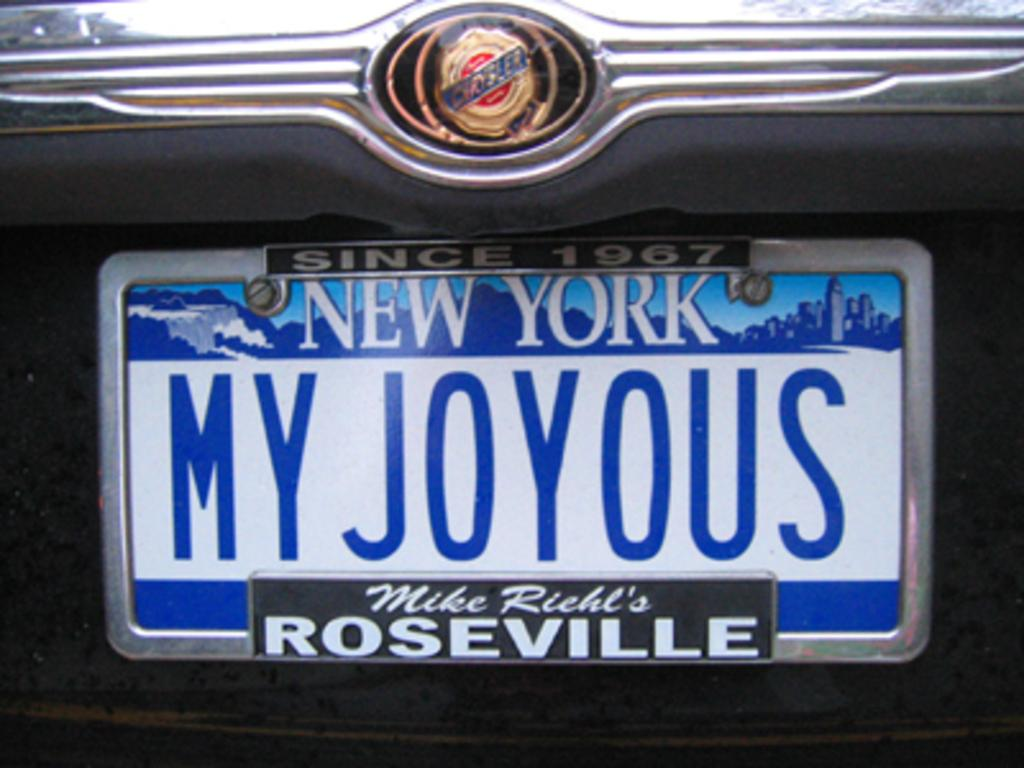<image>
Describe the image concisely. A New York license plate reads "MY JOYOUS." 